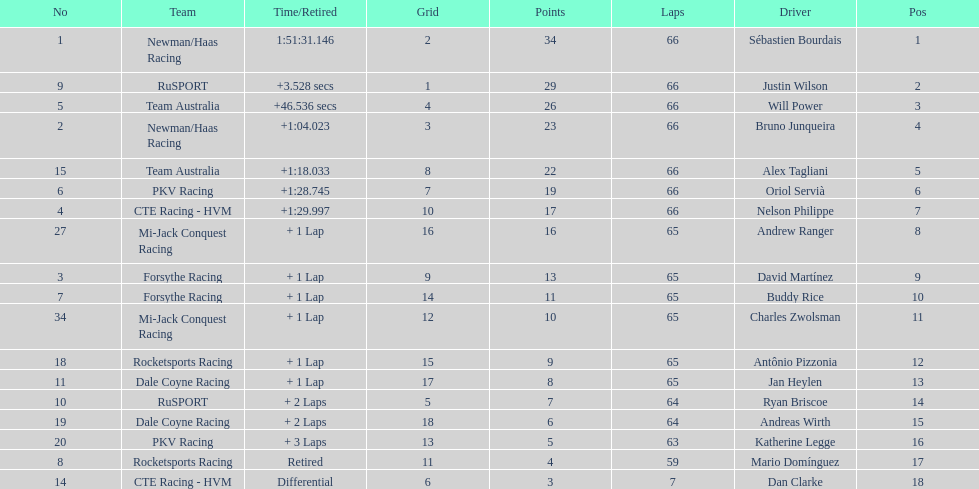How many drivers did not make more than 60 laps? 2. 